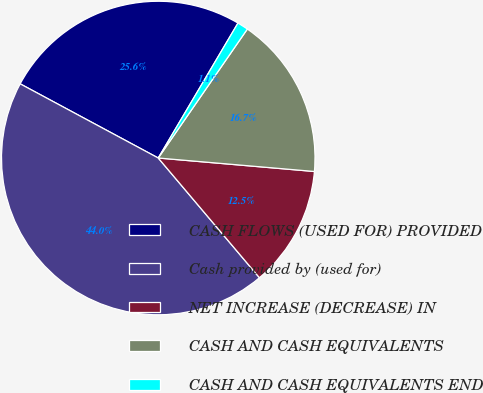<chart> <loc_0><loc_0><loc_500><loc_500><pie_chart><fcel>CASH FLOWS (USED FOR) PROVIDED<fcel>Cash provided by (used for)<fcel>NET INCREASE (DECREASE) IN<fcel>CASH AND CASH EQUIVALENTS<fcel>CASH AND CASH EQUIVALENTS END<nl><fcel>25.65%<fcel>44.02%<fcel>12.46%<fcel>16.75%<fcel>1.13%<nl></chart> 